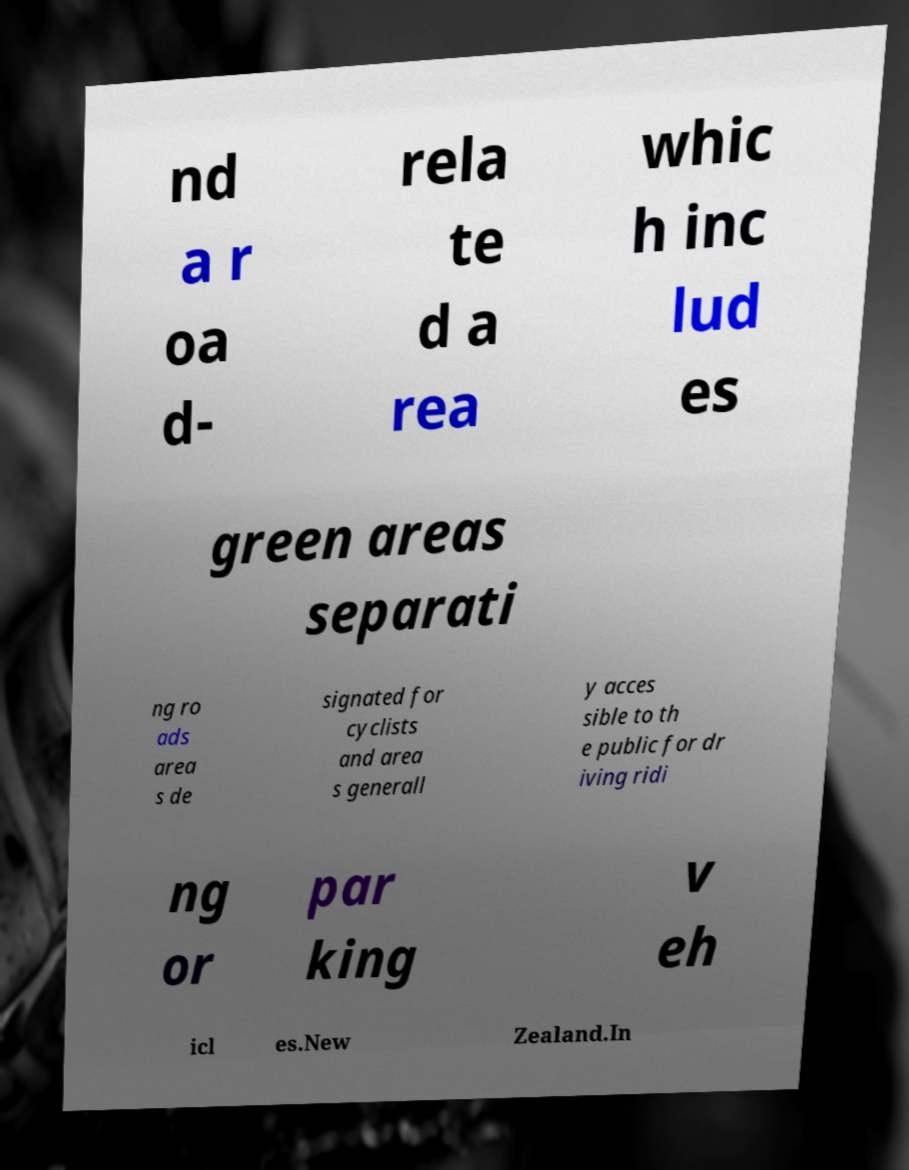Could you assist in decoding the text presented in this image and type it out clearly? nd a r oa d- rela te d a rea whic h inc lud es green areas separati ng ro ads area s de signated for cyclists and area s generall y acces sible to th e public for dr iving ridi ng or par king v eh icl es.New Zealand.In 